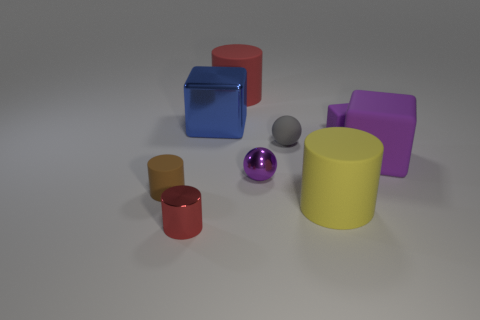What is the material of the red thing behind the brown cylinder?
Provide a succinct answer. Rubber. Is there a green thing that has the same shape as the small gray matte thing?
Offer a very short reply. No. How many other purple things are the same shape as the big purple thing?
Provide a short and direct response. 1. Does the red cylinder in front of the blue object have the same size as the purple thing left of the yellow cylinder?
Your response must be concise. Yes. What is the shape of the red object to the right of the big block that is behind the matte ball?
Give a very brief answer. Cylinder. Are there the same number of cylinders behind the tiny gray ball and large brown matte things?
Your answer should be compact. No. There is a red object that is to the left of the big block left of the large matte cylinder that is behind the gray thing; what is its material?
Make the answer very short. Metal. Are there any blue shiny cubes of the same size as the yellow matte object?
Keep it short and to the point. Yes. What shape is the large purple matte thing?
Make the answer very short. Cube. How many spheres are large matte objects or small red shiny things?
Your response must be concise. 0. 